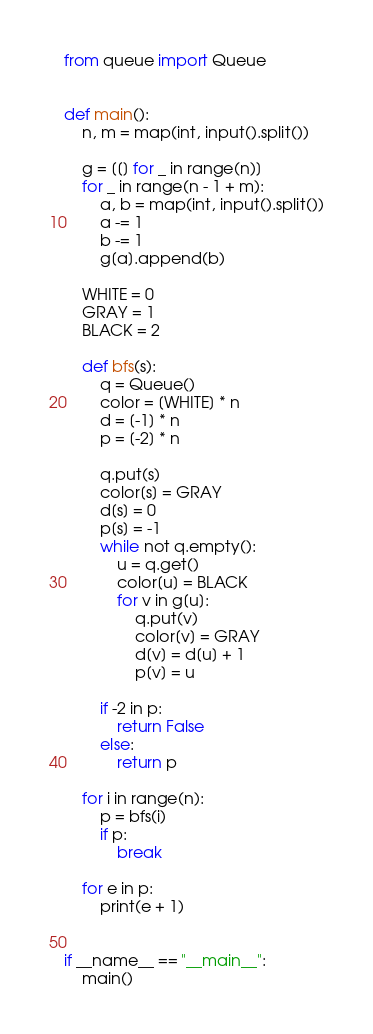Convert code to text. <code><loc_0><loc_0><loc_500><loc_500><_Python_>from queue import Queue


def main():
    n, m = map(int, input().split())

    g = [[] for _ in range(n)]
    for _ in range(n - 1 + m):
        a, b = map(int, input().split())
        a -= 1
        b -= 1
        g[a].append(b)

    WHITE = 0
    GRAY = 1
    BLACK = 2

    def bfs(s):
        q = Queue()
        color = [WHITE] * n
        d = [-1] * n
        p = [-2] * n

        q.put(s)
        color[s] = GRAY
        d[s] = 0
        p[s] = -1
        while not q.empty():
            u = q.get()
            color[u] = BLACK
            for v in g[u]:
                q.put(v)
                color[v] = GRAY
                d[v] = d[u] + 1
                p[v] = u

        if -2 in p:
            return False
        else:
            return p

    for i in range(n):
        p = bfs(i)
        if p:
            break

    for e in p:
        print(e + 1)


if __name__ == "__main__":
    main()
</code> 